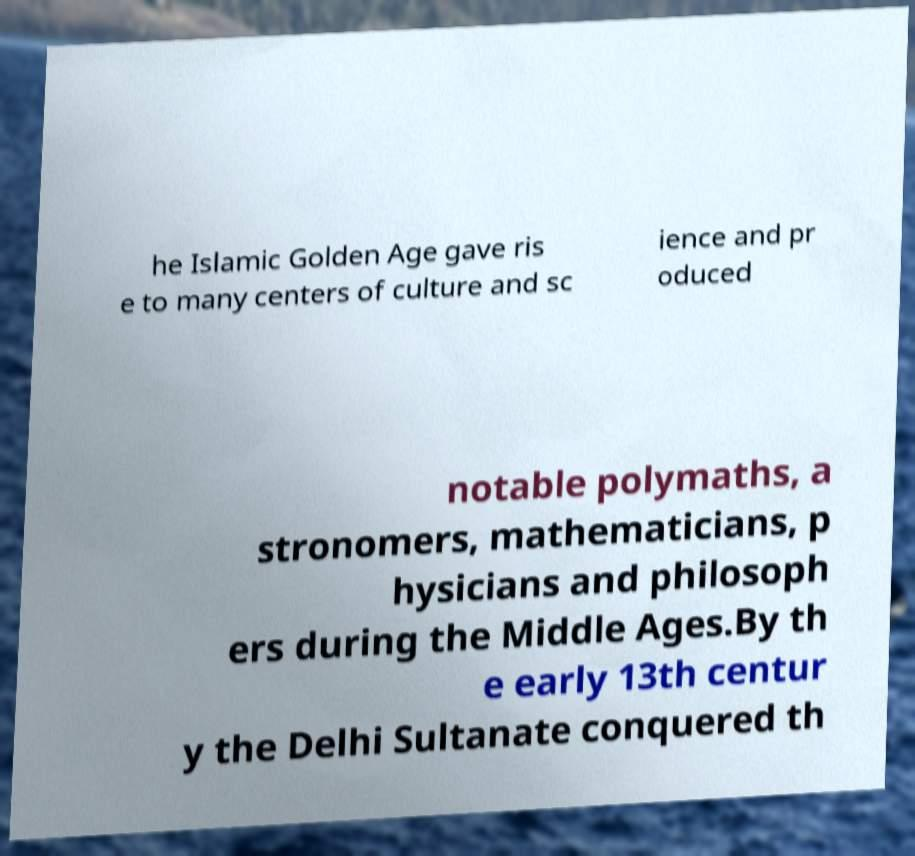Can you read and provide the text displayed in the image?This photo seems to have some interesting text. Can you extract and type it out for me? he Islamic Golden Age gave ris e to many centers of culture and sc ience and pr oduced notable polymaths, a stronomers, mathematicians, p hysicians and philosoph ers during the Middle Ages.By th e early 13th centur y the Delhi Sultanate conquered th 